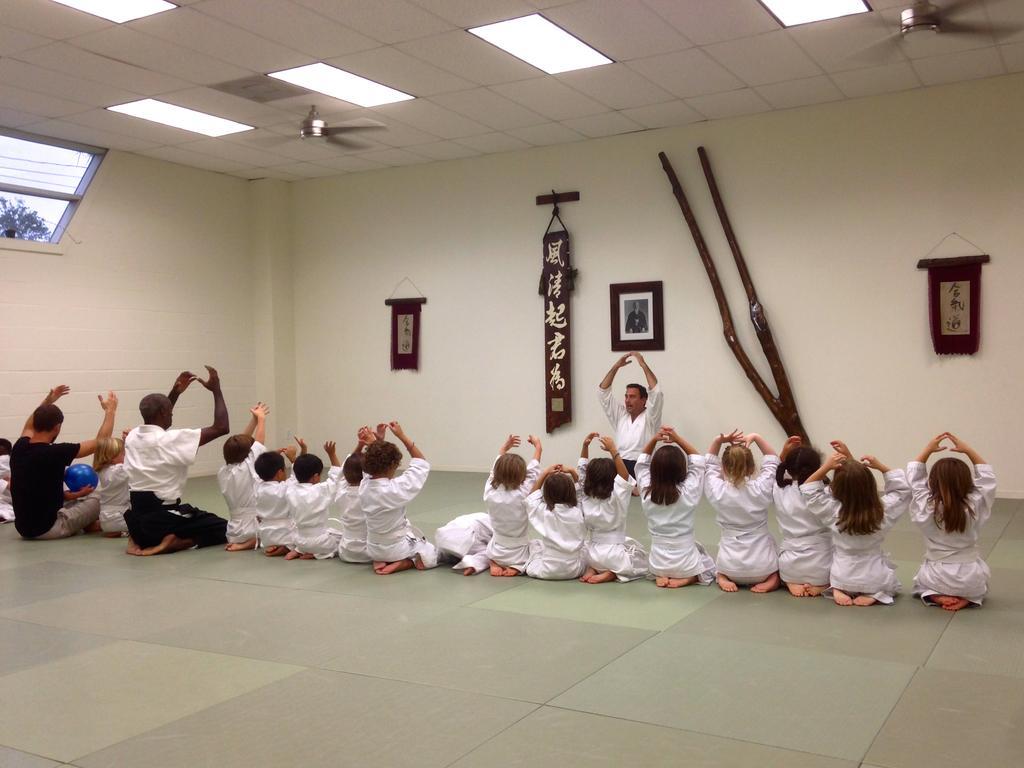Please provide a concise description of this image. People are sitting in a hall and raising their hands. They are wearing white dresses. A person at the left is wearing a black t shirt. A person is holding a blue ball. A person is sitting at the back. There are photo frames and other items hanging on the wall. There are lights and fans on the top. There is a ventilator at the left through which we can see a tree. 